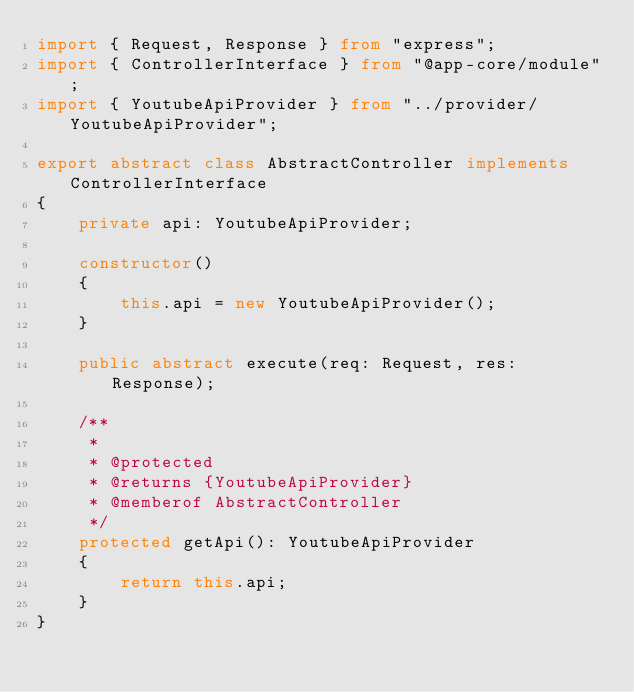Convert code to text. <code><loc_0><loc_0><loc_500><loc_500><_TypeScript_>import { Request, Response } from "express";
import { ControllerInterface } from "@app-core/module";
import { YoutubeApiProvider } from "../provider/YoutubeApiProvider";

export abstract class AbstractController implements ControllerInterface
{
    private api: YoutubeApiProvider;

    constructor()
    {
        this.api = new YoutubeApiProvider();
    }

    public abstract execute(req: Request, res: Response);

    /**
     *
     * @protected
     * @returns {YoutubeApiProvider}
     * @memberof AbstractController
     */
    protected getApi(): YoutubeApiProvider
    {
        return this.api;
    }
}
</code> 